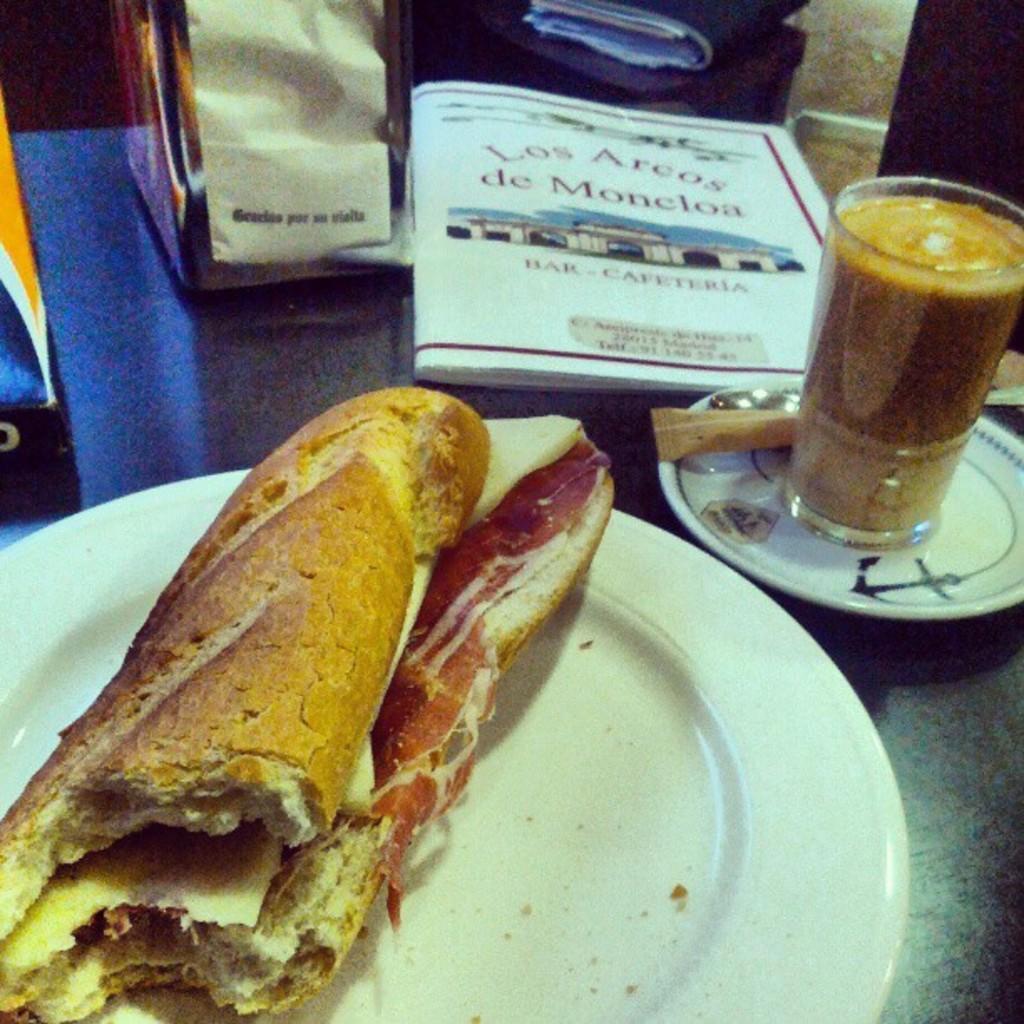Can you describe this image briefly? In the image there is a food item served on a plate and beside that there is a juice in the glass and beside the glass there is a book and two covers. 